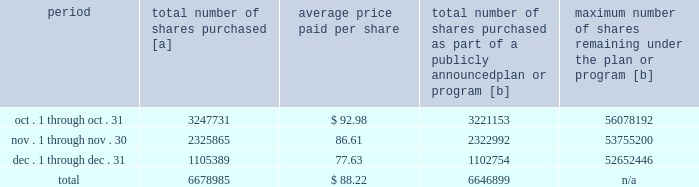Five-year performance comparison 2013 the following graph provides an indicator of cumulative total shareholder returns for the corporation as compared to the peer group index ( described above ) , the dj trans , and the s&p 500 .
The graph assumes that $ 100 was invested in the common stock of union pacific corporation and each index on december 31 , 2010 and that all dividends were reinvested .
The information below is historical in nature and is not necessarily indicative of future performance .
Purchases of equity securities 2013 during 2015 , we repurchased 36921641 shares of our common stock at an average price of $ 99.16 .
The table presents common stock repurchases during each month for the fourth quarter of 2015 : period total number of shares purchased [a] average price paid per share total number of shares purchased as part of a publicly announced plan or program [b] maximum number of shares remaining under the plan or program [b] .
[a] total number of shares purchased during the quarter includes approximately 32086 shares delivered or attested to upc by employees to pay stock option exercise prices , satisfy excess tax withholding obligations for stock option exercises or vesting of retention units , and pay withholding obligations for vesting of retention shares .
[b] effective january 1 , 2014 , our board of directors authorized the repurchase of up to 120 million shares of our common stock by december 31 , 2017 .
These repurchases may be made on the open market or through other transactions .
Our management has sole discretion with respect to determining the timing and amount of these transactions. .
For the fourth quarter ended december 31 , 2015 what was the percent of the total number of shares purchased in november? 
Computations: (2325865 / 6678985)
Answer: 0.34824. 